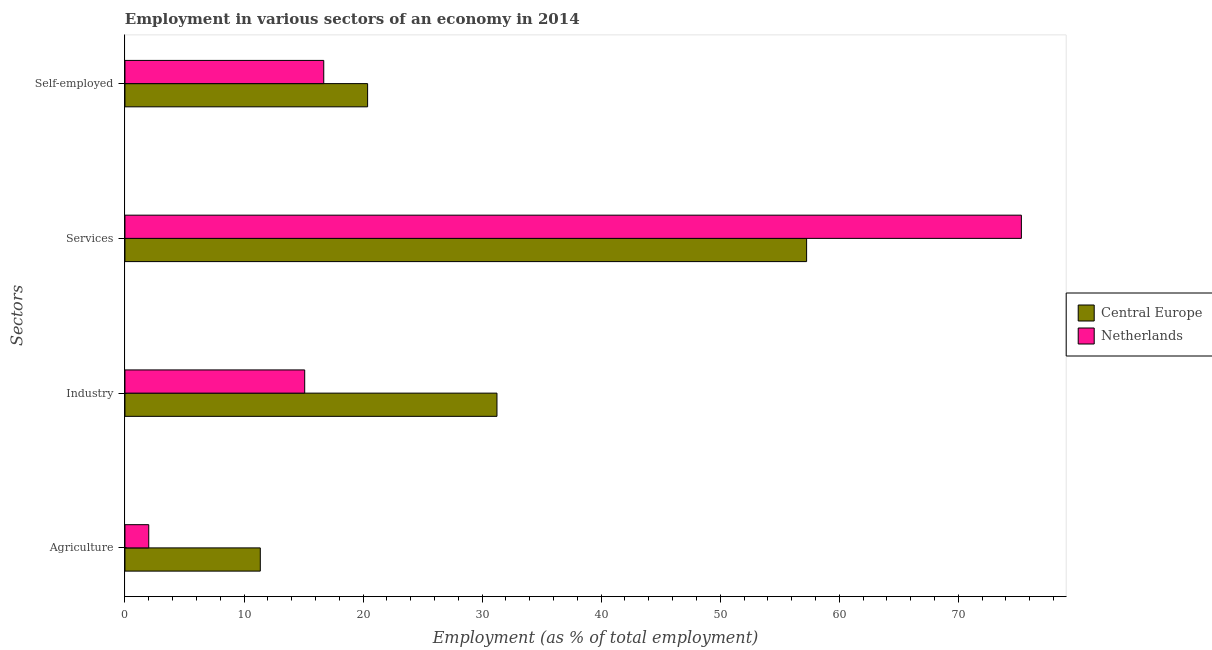How many groups of bars are there?
Provide a succinct answer. 4. Are the number of bars per tick equal to the number of legend labels?
Ensure brevity in your answer.  Yes. How many bars are there on the 1st tick from the top?
Keep it short and to the point. 2. How many bars are there on the 4th tick from the bottom?
Your answer should be very brief. 2. What is the label of the 4th group of bars from the top?
Give a very brief answer. Agriculture. What is the percentage of workers in services in Netherlands?
Your answer should be compact. 75.3. Across all countries, what is the maximum percentage of workers in services?
Provide a succinct answer. 75.3. Across all countries, what is the minimum percentage of self employed workers?
Ensure brevity in your answer.  16.7. In which country was the percentage of workers in industry maximum?
Your answer should be very brief. Central Europe. In which country was the percentage of self employed workers minimum?
Offer a terse response. Netherlands. What is the total percentage of workers in agriculture in the graph?
Your answer should be compact. 13.37. What is the difference between the percentage of workers in industry in Netherlands and that in Central Europe?
Provide a short and direct response. -16.15. What is the difference between the percentage of workers in services in Netherlands and the percentage of workers in agriculture in Central Europe?
Your response must be concise. 63.93. What is the average percentage of workers in services per country?
Keep it short and to the point. 66.28. What is the difference between the percentage of workers in services and percentage of workers in agriculture in Netherlands?
Ensure brevity in your answer.  73.3. In how many countries, is the percentage of workers in industry greater than 10 %?
Ensure brevity in your answer.  2. What is the ratio of the percentage of workers in services in Netherlands to that in Central Europe?
Your response must be concise. 1.32. Is the difference between the percentage of workers in services in Netherlands and Central Europe greater than the difference between the percentage of self employed workers in Netherlands and Central Europe?
Your response must be concise. Yes. What is the difference between the highest and the second highest percentage of workers in services?
Your response must be concise. 18.04. What is the difference between the highest and the lowest percentage of workers in agriculture?
Provide a short and direct response. 9.37. What does the 2nd bar from the top in Services represents?
Give a very brief answer. Central Europe. Is it the case that in every country, the sum of the percentage of workers in agriculture and percentage of workers in industry is greater than the percentage of workers in services?
Ensure brevity in your answer.  No. Are all the bars in the graph horizontal?
Provide a short and direct response. Yes. Where does the legend appear in the graph?
Keep it short and to the point. Center right. What is the title of the graph?
Your response must be concise. Employment in various sectors of an economy in 2014. What is the label or title of the X-axis?
Your answer should be very brief. Employment (as % of total employment). What is the label or title of the Y-axis?
Provide a short and direct response. Sectors. What is the Employment (as % of total employment) of Central Europe in Agriculture?
Your response must be concise. 11.37. What is the Employment (as % of total employment) of Central Europe in Industry?
Your answer should be very brief. 31.25. What is the Employment (as % of total employment) in Netherlands in Industry?
Your answer should be compact. 15.1. What is the Employment (as % of total employment) of Central Europe in Services?
Keep it short and to the point. 57.26. What is the Employment (as % of total employment) in Netherlands in Services?
Keep it short and to the point. 75.3. What is the Employment (as % of total employment) of Central Europe in Self-employed?
Provide a succinct answer. 20.38. What is the Employment (as % of total employment) in Netherlands in Self-employed?
Your response must be concise. 16.7. Across all Sectors, what is the maximum Employment (as % of total employment) in Central Europe?
Provide a succinct answer. 57.26. Across all Sectors, what is the maximum Employment (as % of total employment) in Netherlands?
Keep it short and to the point. 75.3. Across all Sectors, what is the minimum Employment (as % of total employment) of Central Europe?
Ensure brevity in your answer.  11.37. Across all Sectors, what is the minimum Employment (as % of total employment) in Netherlands?
Keep it short and to the point. 2. What is the total Employment (as % of total employment) of Central Europe in the graph?
Offer a very short reply. 120.26. What is the total Employment (as % of total employment) in Netherlands in the graph?
Give a very brief answer. 109.1. What is the difference between the Employment (as % of total employment) in Central Europe in Agriculture and that in Industry?
Provide a succinct answer. -19.88. What is the difference between the Employment (as % of total employment) in Netherlands in Agriculture and that in Industry?
Give a very brief answer. -13.1. What is the difference between the Employment (as % of total employment) of Central Europe in Agriculture and that in Services?
Offer a very short reply. -45.89. What is the difference between the Employment (as % of total employment) in Netherlands in Agriculture and that in Services?
Your answer should be very brief. -73.3. What is the difference between the Employment (as % of total employment) of Central Europe in Agriculture and that in Self-employed?
Provide a short and direct response. -9.01. What is the difference between the Employment (as % of total employment) in Netherlands in Agriculture and that in Self-employed?
Give a very brief answer. -14.7. What is the difference between the Employment (as % of total employment) in Central Europe in Industry and that in Services?
Offer a terse response. -26.01. What is the difference between the Employment (as % of total employment) in Netherlands in Industry and that in Services?
Your answer should be very brief. -60.2. What is the difference between the Employment (as % of total employment) in Central Europe in Industry and that in Self-employed?
Keep it short and to the point. 10.87. What is the difference between the Employment (as % of total employment) in Central Europe in Services and that in Self-employed?
Ensure brevity in your answer.  36.88. What is the difference between the Employment (as % of total employment) of Netherlands in Services and that in Self-employed?
Offer a very short reply. 58.6. What is the difference between the Employment (as % of total employment) in Central Europe in Agriculture and the Employment (as % of total employment) in Netherlands in Industry?
Your answer should be very brief. -3.73. What is the difference between the Employment (as % of total employment) of Central Europe in Agriculture and the Employment (as % of total employment) of Netherlands in Services?
Keep it short and to the point. -63.93. What is the difference between the Employment (as % of total employment) of Central Europe in Agriculture and the Employment (as % of total employment) of Netherlands in Self-employed?
Your response must be concise. -5.33. What is the difference between the Employment (as % of total employment) of Central Europe in Industry and the Employment (as % of total employment) of Netherlands in Services?
Provide a succinct answer. -44.05. What is the difference between the Employment (as % of total employment) of Central Europe in Industry and the Employment (as % of total employment) of Netherlands in Self-employed?
Give a very brief answer. 14.55. What is the difference between the Employment (as % of total employment) in Central Europe in Services and the Employment (as % of total employment) in Netherlands in Self-employed?
Keep it short and to the point. 40.56. What is the average Employment (as % of total employment) in Central Europe per Sectors?
Ensure brevity in your answer.  30.07. What is the average Employment (as % of total employment) of Netherlands per Sectors?
Your response must be concise. 27.27. What is the difference between the Employment (as % of total employment) of Central Europe and Employment (as % of total employment) of Netherlands in Agriculture?
Your response must be concise. 9.37. What is the difference between the Employment (as % of total employment) of Central Europe and Employment (as % of total employment) of Netherlands in Industry?
Provide a succinct answer. 16.15. What is the difference between the Employment (as % of total employment) in Central Europe and Employment (as % of total employment) in Netherlands in Services?
Give a very brief answer. -18.04. What is the difference between the Employment (as % of total employment) in Central Europe and Employment (as % of total employment) in Netherlands in Self-employed?
Make the answer very short. 3.68. What is the ratio of the Employment (as % of total employment) in Central Europe in Agriculture to that in Industry?
Ensure brevity in your answer.  0.36. What is the ratio of the Employment (as % of total employment) of Netherlands in Agriculture to that in Industry?
Give a very brief answer. 0.13. What is the ratio of the Employment (as % of total employment) in Central Europe in Agriculture to that in Services?
Make the answer very short. 0.2. What is the ratio of the Employment (as % of total employment) in Netherlands in Agriculture to that in Services?
Your answer should be very brief. 0.03. What is the ratio of the Employment (as % of total employment) of Central Europe in Agriculture to that in Self-employed?
Offer a very short reply. 0.56. What is the ratio of the Employment (as % of total employment) in Netherlands in Agriculture to that in Self-employed?
Provide a short and direct response. 0.12. What is the ratio of the Employment (as % of total employment) of Central Europe in Industry to that in Services?
Your response must be concise. 0.55. What is the ratio of the Employment (as % of total employment) in Netherlands in Industry to that in Services?
Keep it short and to the point. 0.2. What is the ratio of the Employment (as % of total employment) of Central Europe in Industry to that in Self-employed?
Your answer should be very brief. 1.53. What is the ratio of the Employment (as % of total employment) in Netherlands in Industry to that in Self-employed?
Give a very brief answer. 0.9. What is the ratio of the Employment (as % of total employment) in Central Europe in Services to that in Self-employed?
Your response must be concise. 2.81. What is the ratio of the Employment (as % of total employment) of Netherlands in Services to that in Self-employed?
Offer a terse response. 4.51. What is the difference between the highest and the second highest Employment (as % of total employment) in Central Europe?
Offer a very short reply. 26.01. What is the difference between the highest and the second highest Employment (as % of total employment) of Netherlands?
Provide a short and direct response. 58.6. What is the difference between the highest and the lowest Employment (as % of total employment) of Central Europe?
Give a very brief answer. 45.89. What is the difference between the highest and the lowest Employment (as % of total employment) in Netherlands?
Offer a very short reply. 73.3. 